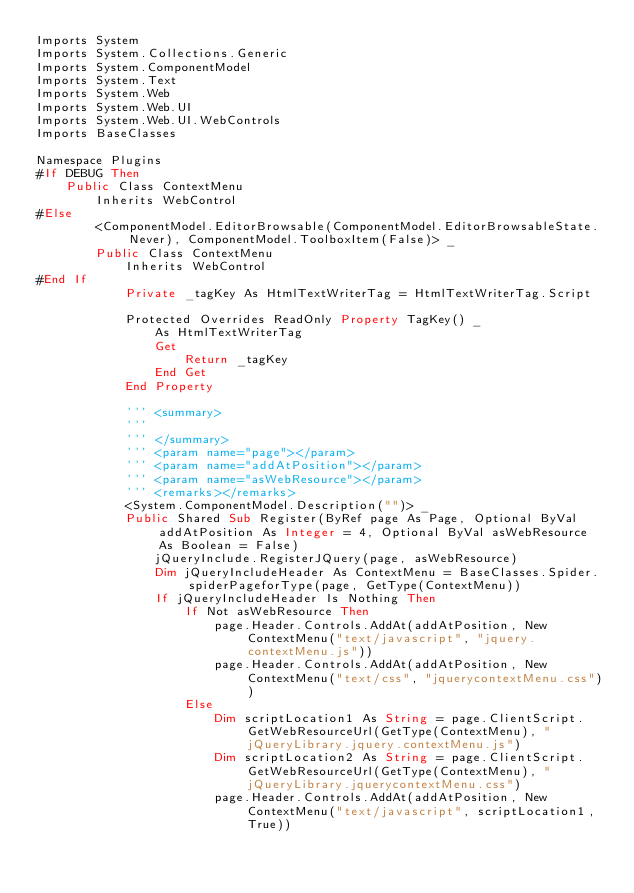<code> <loc_0><loc_0><loc_500><loc_500><_VisualBasic_>Imports System
Imports System.Collections.Generic
Imports System.ComponentModel
Imports System.Text
Imports System.Web
Imports System.Web.UI
Imports System.Web.UI.WebControls
Imports BaseClasses

Namespace Plugins
#If DEBUG Then
    Public Class ContextMenu
        Inherits WebControl
#Else
        <ComponentModel.EditorBrowsable(ComponentModel.EditorBrowsableState.Never), ComponentModel.ToolboxItem(False)> _
        Public Class ContextMenu
            Inherits WebControl
#End If
            Private _tagKey As HtmlTextWriterTag = HtmlTextWriterTag.Script

            Protected Overrides ReadOnly Property TagKey() _
                As HtmlTextWriterTag
                Get
                    Return _tagKey
                End Get
            End Property

            ''' <summary>
            ''' 
            ''' </summary>
            ''' <param name="page"></param>
            ''' <param name="addAtPosition"></param>
            ''' <param name="asWebResource"></param>
            ''' <remarks></remarks>
            <System.ComponentModel.Description("")> _
            Public Shared Sub Register(ByRef page As Page, Optional ByVal addAtPosition As Integer = 4, Optional ByVal asWebResource As Boolean = False)
                jQueryInclude.RegisterJQuery(page, asWebResource)
                Dim jQueryIncludeHeader As ContextMenu = BaseClasses.Spider.spiderPageforType(page, GetType(ContextMenu))
                If jQueryIncludeHeader Is Nothing Then
                    If Not asWebResource Then
                        page.Header.Controls.AddAt(addAtPosition, New ContextMenu("text/javascript", "jquery.contextMenu.js"))
                        page.Header.Controls.AddAt(addAtPosition, New ContextMenu("text/css", "jquerycontextMenu.css"))
                    Else
                        Dim scriptLocation1 As String = page.ClientScript.GetWebResourceUrl(GetType(ContextMenu), "jQueryLibrary.jquery.contextMenu.js")
                        Dim scriptLocation2 As String = page.ClientScript.GetWebResourceUrl(GetType(ContextMenu), "jQueryLibrary.jquerycontextMenu.css")
                        page.Header.Controls.AddAt(addAtPosition, New ContextMenu("text/javascript", scriptLocation1, True))</code> 